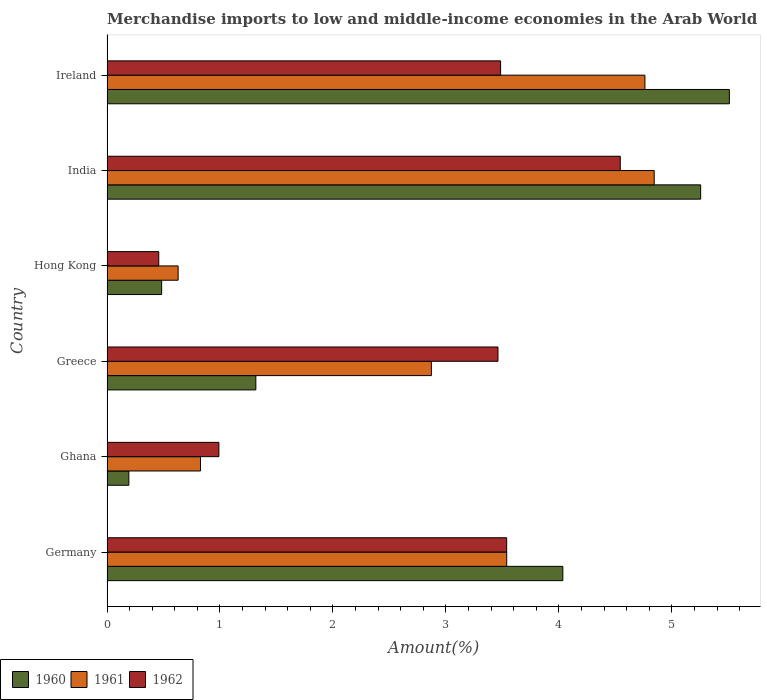How many different coloured bars are there?
Offer a terse response. 3. Are the number of bars per tick equal to the number of legend labels?
Your answer should be compact. Yes. Are the number of bars on each tick of the Y-axis equal?
Your answer should be very brief. Yes. What is the label of the 2nd group of bars from the top?
Provide a succinct answer. India. In how many cases, is the number of bars for a given country not equal to the number of legend labels?
Keep it short and to the point. 0. What is the percentage of amount earned from merchandise imports in 1962 in Greece?
Your response must be concise. 3.46. Across all countries, what is the maximum percentage of amount earned from merchandise imports in 1961?
Your answer should be very brief. 4.84. Across all countries, what is the minimum percentage of amount earned from merchandise imports in 1960?
Provide a succinct answer. 0.19. In which country was the percentage of amount earned from merchandise imports in 1960 minimum?
Provide a short and direct response. Ghana. What is the total percentage of amount earned from merchandise imports in 1960 in the graph?
Provide a succinct answer. 16.79. What is the difference between the percentage of amount earned from merchandise imports in 1961 in Hong Kong and that in Ireland?
Ensure brevity in your answer.  -4.13. What is the difference between the percentage of amount earned from merchandise imports in 1962 in Greece and the percentage of amount earned from merchandise imports in 1960 in Germany?
Provide a short and direct response. -0.57. What is the average percentage of amount earned from merchandise imports in 1961 per country?
Offer a very short reply. 2.91. What is the difference between the percentage of amount earned from merchandise imports in 1960 and percentage of amount earned from merchandise imports in 1961 in Ghana?
Ensure brevity in your answer.  -0.63. What is the ratio of the percentage of amount earned from merchandise imports in 1960 in Germany to that in Ireland?
Offer a very short reply. 0.73. Is the percentage of amount earned from merchandise imports in 1962 in India less than that in Ireland?
Your answer should be very brief. No. What is the difference between the highest and the second highest percentage of amount earned from merchandise imports in 1962?
Make the answer very short. 1.01. What is the difference between the highest and the lowest percentage of amount earned from merchandise imports in 1961?
Your response must be concise. 4.21. What does the 2nd bar from the top in Greece represents?
Give a very brief answer. 1961. What does the 2nd bar from the bottom in Ireland represents?
Offer a terse response. 1961. How many countries are there in the graph?
Your response must be concise. 6. Are the values on the major ticks of X-axis written in scientific E-notation?
Make the answer very short. No. Does the graph contain any zero values?
Your response must be concise. No. Does the graph contain grids?
Provide a succinct answer. No. How many legend labels are there?
Keep it short and to the point. 3. What is the title of the graph?
Your answer should be compact. Merchandise imports to low and middle-income economies in the Arab World. Does "2010" appear as one of the legend labels in the graph?
Offer a very short reply. No. What is the label or title of the X-axis?
Make the answer very short. Amount(%). What is the Amount(%) in 1960 in Germany?
Offer a terse response. 4.03. What is the Amount(%) of 1961 in Germany?
Your answer should be very brief. 3.54. What is the Amount(%) in 1962 in Germany?
Offer a terse response. 3.54. What is the Amount(%) of 1960 in Ghana?
Give a very brief answer. 0.19. What is the Amount(%) in 1961 in Ghana?
Provide a succinct answer. 0.83. What is the Amount(%) in 1962 in Ghana?
Provide a short and direct response. 0.99. What is the Amount(%) in 1960 in Greece?
Offer a very short reply. 1.32. What is the Amount(%) in 1961 in Greece?
Your response must be concise. 2.87. What is the Amount(%) of 1962 in Greece?
Your answer should be compact. 3.46. What is the Amount(%) in 1960 in Hong Kong?
Your answer should be compact. 0.48. What is the Amount(%) in 1961 in Hong Kong?
Provide a short and direct response. 0.63. What is the Amount(%) of 1962 in Hong Kong?
Ensure brevity in your answer.  0.46. What is the Amount(%) in 1960 in India?
Offer a very short reply. 5.25. What is the Amount(%) of 1961 in India?
Your answer should be very brief. 4.84. What is the Amount(%) in 1962 in India?
Offer a terse response. 4.54. What is the Amount(%) in 1960 in Ireland?
Provide a succinct answer. 5.51. What is the Amount(%) in 1961 in Ireland?
Make the answer very short. 4.76. What is the Amount(%) of 1962 in Ireland?
Offer a terse response. 3.48. Across all countries, what is the maximum Amount(%) of 1960?
Offer a terse response. 5.51. Across all countries, what is the maximum Amount(%) of 1961?
Provide a short and direct response. 4.84. Across all countries, what is the maximum Amount(%) of 1962?
Keep it short and to the point. 4.54. Across all countries, what is the minimum Amount(%) in 1960?
Provide a short and direct response. 0.19. Across all countries, what is the minimum Amount(%) of 1961?
Offer a very short reply. 0.63. Across all countries, what is the minimum Amount(%) in 1962?
Provide a succinct answer. 0.46. What is the total Amount(%) of 1960 in the graph?
Your answer should be very brief. 16.79. What is the total Amount(%) of 1961 in the graph?
Keep it short and to the point. 17.47. What is the total Amount(%) in 1962 in the graph?
Your answer should be very brief. 16.47. What is the difference between the Amount(%) in 1960 in Germany and that in Ghana?
Keep it short and to the point. 3.84. What is the difference between the Amount(%) of 1961 in Germany and that in Ghana?
Your response must be concise. 2.71. What is the difference between the Amount(%) in 1962 in Germany and that in Ghana?
Make the answer very short. 2.55. What is the difference between the Amount(%) of 1960 in Germany and that in Greece?
Ensure brevity in your answer.  2.72. What is the difference between the Amount(%) of 1961 in Germany and that in Greece?
Your answer should be compact. 0.67. What is the difference between the Amount(%) in 1962 in Germany and that in Greece?
Keep it short and to the point. 0.08. What is the difference between the Amount(%) in 1960 in Germany and that in Hong Kong?
Offer a very short reply. 3.55. What is the difference between the Amount(%) in 1961 in Germany and that in Hong Kong?
Offer a very short reply. 2.91. What is the difference between the Amount(%) in 1962 in Germany and that in Hong Kong?
Your response must be concise. 3.08. What is the difference between the Amount(%) in 1960 in Germany and that in India?
Your response must be concise. -1.22. What is the difference between the Amount(%) of 1961 in Germany and that in India?
Your answer should be very brief. -1.31. What is the difference between the Amount(%) in 1962 in Germany and that in India?
Provide a short and direct response. -1.01. What is the difference between the Amount(%) of 1960 in Germany and that in Ireland?
Keep it short and to the point. -1.47. What is the difference between the Amount(%) of 1961 in Germany and that in Ireland?
Make the answer very short. -1.22. What is the difference between the Amount(%) of 1962 in Germany and that in Ireland?
Offer a terse response. 0.05. What is the difference between the Amount(%) of 1960 in Ghana and that in Greece?
Give a very brief answer. -1.12. What is the difference between the Amount(%) in 1961 in Ghana and that in Greece?
Make the answer very short. -2.04. What is the difference between the Amount(%) in 1962 in Ghana and that in Greece?
Give a very brief answer. -2.47. What is the difference between the Amount(%) in 1960 in Ghana and that in Hong Kong?
Offer a terse response. -0.29. What is the difference between the Amount(%) of 1961 in Ghana and that in Hong Kong?
Your answer should be compact. 0.2. What is the difference between the Amount(%) in 1962 in Ghana and that in Hong Kong?
Keep it short and to the point. 0.53. What is the difference between the Amount(%) of 1960 in Ghana and that in India?
Your answer should be compact. -5.06. What is the difference between the Amount(%) in 1961 in Ghana and that in India?
Offer a very short reply. -4.02. What is the difference between the Amount(%) of 1962 in Ghana and that in India?
Your answer should be very brief. -3.55. What is the difference between the Amount(%) of 1960 in Ghana and that in Ireland?
Provide a short and direct response. -5.32. What is the difference between the Amount(%) of 1961 in Ghana and that in Ireland?
Make the answer very short. -3.93. What is the difference between the Amount(%) in 1962 in Ghana and that in Ireland?
Provide a short and direct response. -2.49. What is the difference between the Amount(%) of 1960 in Greece and that in Hong Kong?
Make the answer very short. 0.83. What is the difference between the Amount(%) in 1961 in Greece and that in Hong Kong?
Your response must be concise. 2.24. What is the difference between the Amount(%) in 1962 in Greece and that in Hong Kong?
Offer a very short reply. 3. What is the difference between the Amount(%) of 1960 in Greece and that in India?
Provide a short and direct response. -3.94. What is the difference between the Amount(%) in 1961 in Greece and that in India?
Make the answer very short. -1.97. What is the difference between the Amount(%) in 1962 in Greece and that in India?
Provide a short and direct response. -1.08. What is the difference between the Amount(%) in 1960 in Greece and that in Ireland?
Provide a succinct answer. -4.19. What is the difference between the Amount(%) in 1961 in Greece and that in Ireland?
Your answer should be compact. -1.89. What is the difference between the Amount(%) of 1962 in Greece and that in Ireland?
Offer a very short reply. -0.02. What is the difference between the Amount(%) of 1960 in Hong Kong and that in India?
Ensure brevity in your answer.  -4.77. What is the difference between the Amount(%) in 1961 in Hong Kong and that in India?
Provide a succinct answer. -4.21. What is the difference between the Amount(%) of 1962 in Hong Kong and that in India?
Keep it short and to the point. -4.08. What is the difference between the Amount(%) in 1960 in Hong Kong and that in Ireland?
Provide a succinct answer. -5.03. What is the difference between the Amount(%) of 1961 in Hong Kong and that in Ireland?
Your answer should be very brief. -4.13. What is the difference between the Amount(%) of 1962 in Hong Kong and that in Ireland?
Make the answer very short. -3.03. What is the difference between the Amount(%) in 1960 in India and that in Ireland?
Your answer should be very brief. -0.25. What is the difference between the Amount(%) in 1961 in India and that in Ireland?
Your answer should be very brief. 0.08. What is the difference between the Amount(%) of 1962 in India and that in Ireland?
Make the answer very short. 1.06. What is the difference between the Amount(%) in 1960 in Germany and the Amount(%) in 1961 in Ghana?
Your answer should be compact. 3.21. What is the difference between the Amount(%) in 1960 in Germany and the Amount(%) in 1962 in Ghana?
Ensure brevity in your answer.  3.04. What is the difference between the Amount(%) of 1961 in Germany and the Amount(%) of 1962 in Ghana?
Make the answer very short. 2.55. What is the difference between the Amount(%) of 1960 in Germany and the Amount(%) of 1961 in Greece?
Provide a succinct answer. 1.16. What is the difference between the Amount(%) of 1960 in Germany and the Amount(%) of 1962 in Greece?
Your answer should be compact. 0.57. What is the difference between the Amount(%) of 1961 in Germany and the Amount(%) of 1962 in Greece?
Provide a short and direct response. 0.08. What is the difference between the Amount(%) in 1960 in Germany and the Amount(%) in 1961 in Hong Kong?
Make the answer very short. 3.41. What is the difference between the Amount(%) in 1960 in Germany and the Amount(%) in 1962 in Hong Kong?
Give a very brief answer. 3.58. What is the difference between the Amount(%) of 1961 in Germany and the Amount(%) of 1962 in Hong Kong?
Offer a very short reply. 3.08. What is the difference between the Amount(%) of 1960 in Germany and the Amount(%) of 1961 in India?
Provide a short and direct response. -0.81. What is the difference between the Amount(%) of 1960 in Germany and the Amount(%) of 1962 in India?
Your answer should be very brief. -0.51. What is the difference between the Amount(%) in 1961 in Germany and the Amount(%) in 1962 in India?
Your response must be concise. -1.01. What is the difference between the Amount(%) in 1960 in Germany and the Amount(%) in 1961 in Ireland?
Your answer should be compact. -0.73. What is the difference between the Amount(%) of 1960 in Germany and the Amount(%) of 1962 in Ireland?
Your answer should be very brief. 0.55. What is the difference between the Amount(%) in 1961 in Germany and the Amount(%) in 1962 in Ireland?
Keep it short and to the point. 0.05. What is the difference between the Amount(%) of 1960 in Ghana and the Amount(%) of 1961 in Greece?
Offer a terse response. -2.68. What is the difference between the Amount(%) in 1960 in Ghana and the Amount(%) in 1962 in Greece?
Provide a short and direct response. -3.27. What is the difference between the Amount(%) of 1961 in Ghana and the Amount(%) of 1962 in Greece?
Offer a very short reply. -2.63. What is the difference between the Amount(%) of 1960 in Ghana and the Amount(%) of 1961 in Hong Kong?
Your answer should be compact. -0.44. What is the difference between the Amount(%) in 1960 in Ghana and the Amount(%) in 1962 in Hong Kong?
Your answer should be very brief. -0.26. What is the difference between the Amount(%) of 1961 in Ghana and the Amount(%) of 1962 in Hong Kong?
Ensure brevity in your answer.  0.37. What is the difference between the Amount(%) of 1960 in Ghana and the Amount(%) of 1961 in India?
Make the answer very short. -4.65. What is the difference between the Amount(%) in 1960 in Ghana and the Amount(%) in 1962 in India?
Give a very brief answer. -4.35. What is the difference between the Amount(%) in 1961 in Ghana and the Amount(%) in 1962 in India?
Your answer should be compact. -3.72. What is the difference between the Amount(%) of 1960 in Ghana and the Amount(%) of 1961 in Ireland?
Your answer should be very brief. -4.57. What is the difference between the Amount(%) of 1960 in Ghana and the Amount(%) of 1962 in Ireland?
Keep it short and to the point. -3.29. What is the difference between the Amount(%) of 1961 in Ghana and the Amount(%) of 1962 in Ireland?
Provide a succinct answer. -2.66. What is the difference between the Amount(%) of 1960 in Greece and the Amount(%) of 1961 in Hong Kong?
Make the answer very short. 0.69. What is the difference between the Amount(%) of 1960 in Greece and the Amount(%) of 1962 in Hong Kong?
Keep it short and to the point. 0.86. What is the difference between the Amount(%) in 1961 in Greece and the Amount(%) in 1962 in Hong Kong?
Make the answer very short. 2.41. What is the difference between the Amount(%) of 1960 in Greece and the Amount(%) of 1961 in India?
Provide a short and direct response. -3.53. What is the difference between the Amount(%) of 1960 in Greece and the Amount(%) of 1962 in India?
Offer a very short reply. -3.23. What is the difference between the Amount(%) in 1961 in Greece and the Amount(%) in 1962 in India?
Give a very brief answer. -1.67. What is the difference between the Amount(%) of 1960 in Greece and the Amount(%) of 1961 in Ireland?
Provide a succinct answer. -3.44. What is the difference between the Amount(%) of 1960 in Greece and the Amount(%) of 1962 in Ireland?
Make the answer very short. -2.17. What is the difference between the Amount(%) of 1961 in Greece and the Amount(%) of 1962 in Ireland?
Offer a terse response. -0.61. What is the difference between the Amount(%) in 1960 in Hong Kong and the Amount(%) in 1961 in India?
Your response must be concise. -4.36. What is the difference between the Amount(%) of 1960 in Hong Kong and the Amount(%) of 1962 in India?
Ensure brevity in your answer.  -4.06. What is the difference between the Amount(%) in 1961 in Hong Kong and the Amount(%) in 1962 in India?
Provide a succinct answer. -3.91. What is the difference between the Amount(%) in 1960 in Hong Kong and the Amount(%) in 1961 in Ireland?
Provide a succinct answer. -4.28. What is the difference between the Amount(%) of 1960 in Hong Kong and the Amount(%) of 1962 in Ireland?
Your answer should be compact. -3. What is the difference between the Amount(%) in 1961 in Hong Kong and the Amount(%) in 1962 in Ireland?
Your answer should be compact. -2.85. What is the difference between the Amount(%) of 1960 in India and the Amount(%) of 1961 in Ireland?
Your response must be concise. 0.49. What is the difference between the Amount(%) in 1960 in India and the Amount(%) in 1962 in Ireland?
Provide a succinct answer. 1.77. What is the difference between the Amount(%) of 1961 in India and the Amount(%) of 1962 in Ireland?
Make the answer very short. 1.36. What is the average Amount(%) in 1960 per country?
Your answer should be compact. 2.8. What is the average Amount(%) in 1961 per country?
Ensure brevity in your answer.  2.91. What is the average Amount(%) of 1962 per country?
Give a very brief answer. 2.75. What is the difference between the Amount(%) in 1960 and Amount(%) in 1961 in Germany?
Make the answer very short. 0.5. What is the difference between the Amount(%) in 1960 and Amount(%) in 1962 in Germany?
Provide a short and direct response. 0.5. What is the difference between the Amount(%) of 1960 and Amount(%) of 1961 in Ghana?
Your answer should be compact. -0.63. What is the difference between the Amount(%) of 1960 and Amount(%) of 1962 in Ghana?
Provide a succinct answer. -0.8. What is the difference between the Amount(%) of 1961 and Amount(%) of 1962 in Ghana?
Ensure brevity in your answer.  -0.16. What is the difference between the Amount(%) of 1960 and Amount(%) of 1961 in Greece?
Keep it short and to the point. -1.55. What is the difference between the Amount(%) of 1960 and Amount(%) of 1962 in Greece?
Provide a short and direct response. -2.14. What is the difference between the Amount(%) in 1961 and Amount(%) in 1962 in Greece?
Your answer should be very brief. -0.59. What is the difference between the Amount(%) in 1960 and Amount(%) in 1961 in Hong Kong?
Give a very brief answer. -0.15. What is the difference between the Amount(%) of 1960 and Amount(%) of 1962 in Hong Kong?
Your answer should be very brief. 0.03. What is the difference between the Amount(%) in 1961 and Amount(%) in 1962 in Hong Kong?
Your answer should be very brief. 0.17. What is the difference between the Amount(%) of 1960 and Amount(%) of 1961 in India?
Your answer should be compact. 0.41. What is the difference between the Amount(%) of 1960 and Amount(%) of 1962 in India?
Keep it short and to the point. 0.71. What is the difference between the Amount(%) of 1961 and Amount(%) of 1962 in India?
Offer a terse response. 0.3. What is the difference between the Amount(%) in 1960 and Amount(%) in 1961 in Ireland?
Your answer should be compact. 0.75. What is the difference between the Amount(%) in 1960 and Amount(%) in 1962 in Ireland?
Ensure brevity in your answer.  2.02. What is the difference between the Amount(%) of 1961 and Amount(%) of 1962 in Ireland?
Your answer should be compact. 1.28. What is the ratio of the Amount(%) of 1960 in Germany to that in Ghana?
Provide a short and direct response. 20.87. What is the ratio of the Amount(%) of 1961 in Germany to that in Ghana?
Your answer should be compact. 4.28. What is the ratio of the Amount(%) of 1962 in Germany to that in Ghana?
Offer a very short reply. 3.57. What is the ratio of the Amount(%) of 1960 in Germany to that in Greece?
Offer a very short reply. 3.06. What is the ratio of the Amount(%) of 1961 in Germany to that in Greece?
Your answer should be very brief. 1.23. What is the ratio of the Amount(%) in 1962 in Germany to that in Greece?
Your response must be concise. 1.02. What is the ratio of the Amount(%) in 1960 in Germany to that in Hong Kong?
Provide a short and direct response. 8.34. What is the ratio of the Amount(%) of 1961 in Germany to that in Hong Kong?
Your answer should be very brief. 5.62. What is the ratio of the Amount(%) of 1962 in Germany to that in Hong Kong?
Ensure brevity in your answer.  7.72. What is the ratio of the Amount(%) of 1960 in Germany to that in India?
Provide a short and direct response. 0.77. What is the ratio of the Amount(%) in 1961 in Germany to that in India?
Your response must be concise. 0.73. What is the ratio of the Amount(%) in 1962 in Germany to that in India?
Provide a succinct answer. 0.78. What is the ratio of the Amount(%) of 1960 in Germany to that in Ireland?
Keep it short and to the point. 0.73. What is the ratio of the Amount(%) of 1961 in Germany to that in Ireland?
Your response must be concise. 0.74. What is the ratio of the Amount(%) of 1962 in Germany to that in Ireland?
Offer a very short reply. 1.02. What is the ratio of the Amount(%) of 1960 in Ghana to that in Greece?
Ensure brevity in your answer.  0.15. What is the ratio of the Amount(%) in 1961 in Ghana to that in Greece?
Your answer should be compact. 0.29. What is the ratio of the Amount(%) of 1962 in Ghana to that in Greece?
Keep it short and to the point. 0.29. What is the ratio of the Amount(%) in 1960 in Ghana to that in Hong Kong?
Ensure brevity in your answer.  0.4. What is the ratio of the Amount(%) of 1961 in Ghana to that in Hong Kong?
Your answer should be very brief. 1.31. What is the ratio of the Amount(%) in 1962 in Ghana to that in Hong Kong?
Your response must be concise. 2.16. What is the ratio of the Amount(%) of 1960 in Ghana to that in India?
Give a very brief answer. 0.04. What is the ratio of the Amount(%) of 1961 in Ghana to that in India?
Ensure brevity in your answer.  0.17. What is the ratio of the Amount(%) in 1962 in Ghana to that in India?
Offer a very short reply. 0.22. What is the ratio of the Amount(%) in 1960 in Ghana to that in Ireland?
Make the answer very short. 0.04. What is the ratio of the Amount(%) of 1961 in Ghana to that in Ireland?
Provide a succinct answer. 0.17. What is the ratio of the Amount(%) in 1962 in Ghana to that in Ireland?
Provide a succinct answer. 0.28. What is the ratio of the Amount(%) in 1960 in Greece to that in Hong Kong?
Offer a very short reply. 2.72. What is the ratio of the Amount(%) in 1961 in Greece to that in Hong Kong?
Give a very brief answer. 4.56. What is the ratio of the Amount(%) of 1962 in Greece to that in Hong Kong?
Your answer should be very brief. 7.55. What is the ratio of the Amount(%) in 1960 in Greece to that in India?
Your answer should be very brief. 0.25. What is the ratio of the Amount(%) in 1961 in Greece to that in India?
Your answer should be very brief. 0.59. What is the ratio of the Amount(%) of 1962 in Greece to that in India?
Offer a very short reply. 0.76. What is the ratio of the Amount(%) in 1960 in Greece to that in Ireland?
Provide a short and direct response. 0.24. What is the ratio of the Amount(%) in 1961 in Greece to that in Ireland?
Provide a succinct answer. 0.6. What is the ratio of the Amount(%) of 1960 in Hong Kong to that in India?
Your response must be concise. 0.09. What is the ratio of the Amount(%) in 1961 in Hong Kong to that in India?
Your answer should be compact. 0.13. What is the ratio of the Amount(%) of 1962 in Hong Kong to that in India?
Keep it short and to the point. 0.1. What is the ratio of the Amount(%) of 1960 in Hong Kong to that in Ireland?
Your answer should be compact. 0.09. What is the ratio of the Amount(%) in 1961 in Hong Kong to that in Ireland?
Ensure brevity in your answer.  0.13. What is the ratio of the Amount(%) in 1962 in Hong Kong to that in Ireland?
Ensure brevity in your answer.  0.13. What is the ratio of the Amount(%) in 1960 in India to that in Ireland?
Offer a terse response. 0.95. What is the ratio of the Amount(%) in 1961 in India to that in Ireland?
Offer a very short reply. 1.02. What is the ratio of the Amount(%) of 1962 in India to that in Ireland?
Offer a terse response. 1.3. What is the difference between the highest and the second highest Amount(%) of 1960?
Provide a short and direct response. 0.25. What is the difference between the highest and the second highest Amount(%) of 1961?
Offer a very short reply. 0.08. What is the difference between the highest and the second highest Amount(%) in 1962?
Keep it short and to the point. 1.01. What is the difference between the highest and the lowest Amount(%) in 1960?
Give a very brief answer. 5.32. What is the difference between the highest and the lowest Amount(%) of 1961?
Your answer should be compact. 4.21. What is the difference between the highest and the lowest Amount(%) in 1962?
Offer a very short reply. 4.08. 